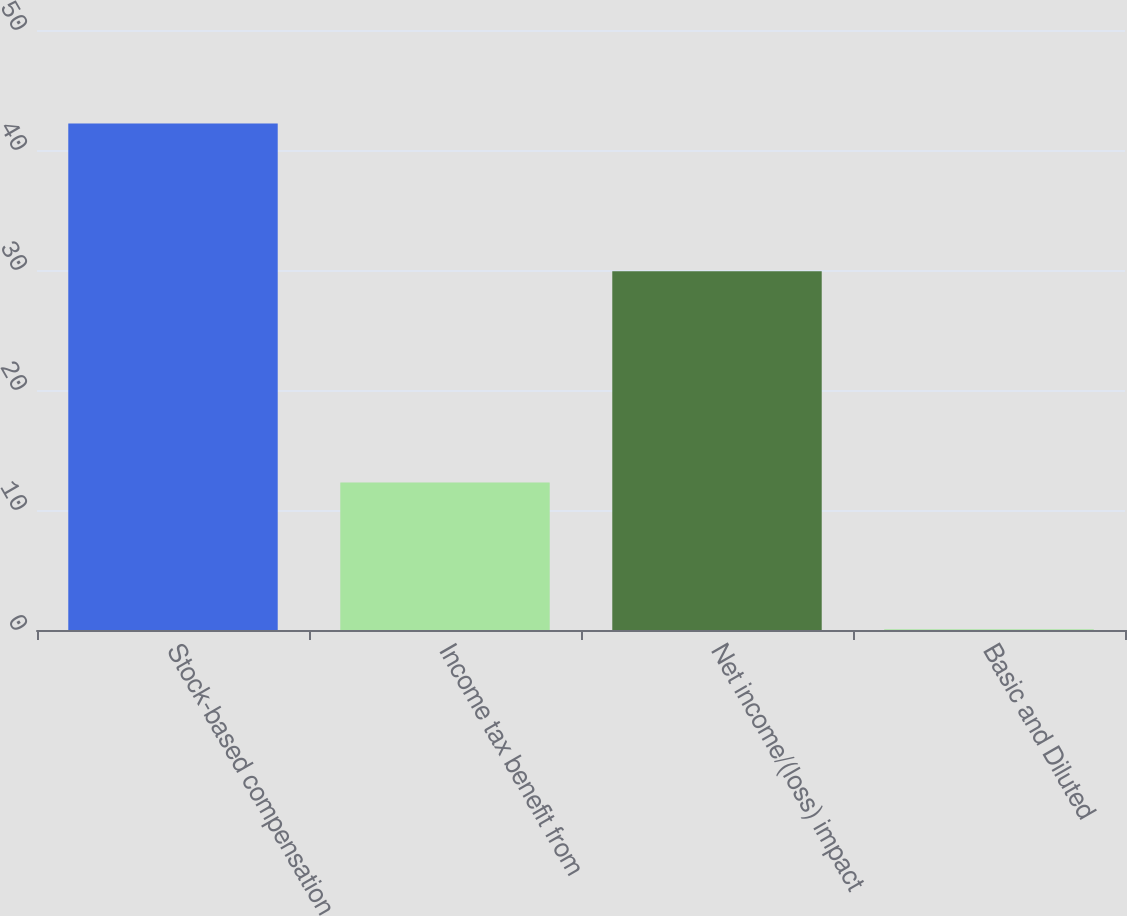Convert chart to OTSL. <chart><loc_0><loc_0><loc_500><loc_500><bar_chart><fcel>Stock-based compensation<fcel>Income tax benefit from<fcel>Net income/(loss) impact<fcel>Basic and Diluted<nl><fcel>42.2<fcel>12.3<fcel>29.9<fcel>0.06<nl></chart> 